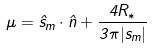<formula> <loc_0><loc_0><loc_500><loc_500>\mu = \hat { s } _ { m } \cdot \hat { n } + \frac { 4 R _ { * } } { 3 \pi | s _ { m } | }</formula> 